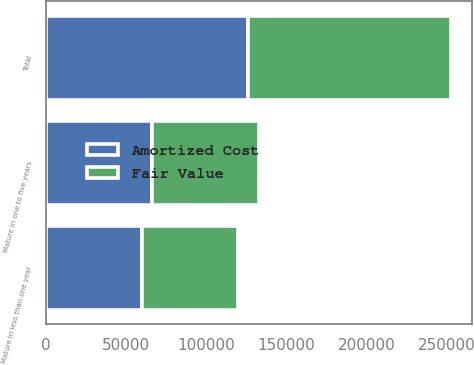Convert chart. <chart><loc_0><loc_0><loc_500><loc_500><stacked_bar_chart><ecel><fcel>Mature in less than one year<fcel>Mature in one to five years<fcel>Total<nl><fcel>Fair Value<fcel>59952<fcel>66742<fcel>126694<nl><fcel>Amortized Cost<fcel>59900<fcel>66367<fcel>126267<nl></chart> 